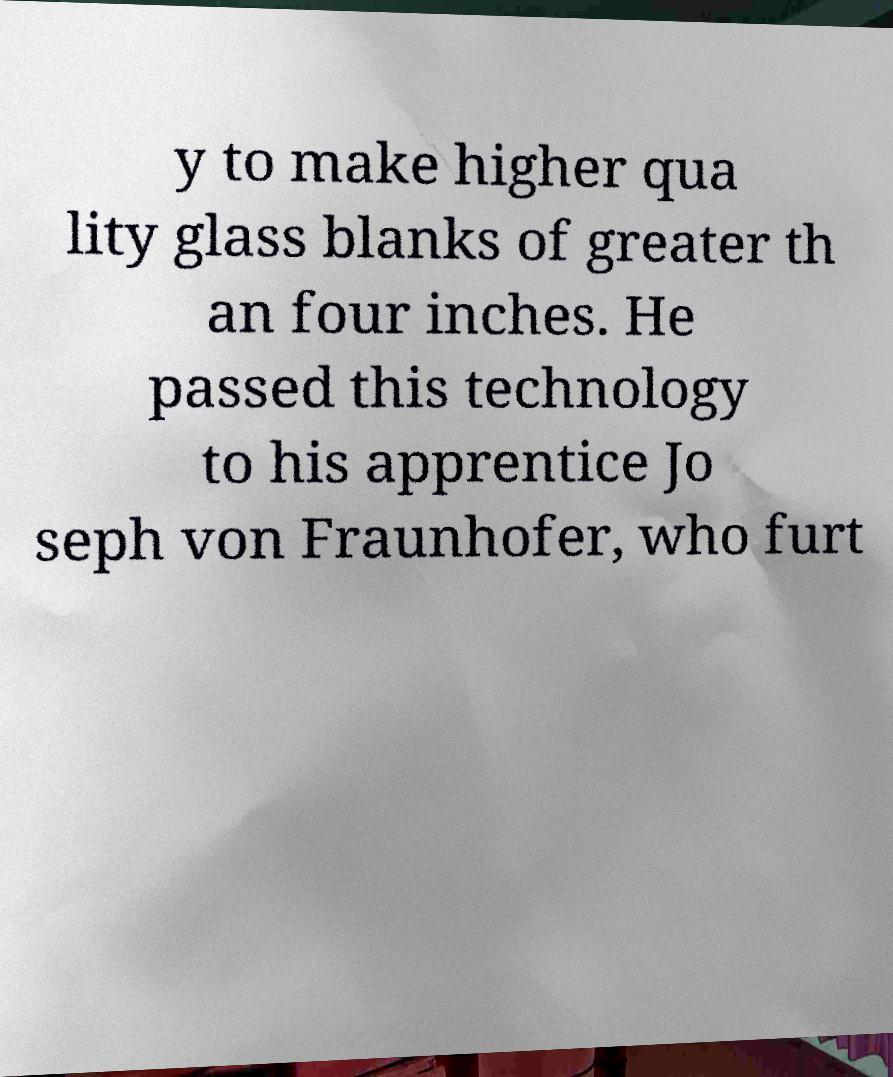What messages or text are displayed in this image? I need them in a readable, typed format. y to make higher qua lity glass blanks of greater th an four inches. He passed this technology to his apprentice Jo seph von Fraunhofer, who furt 